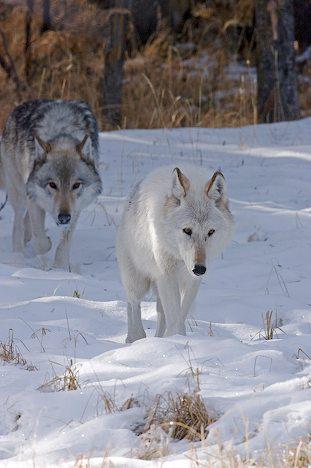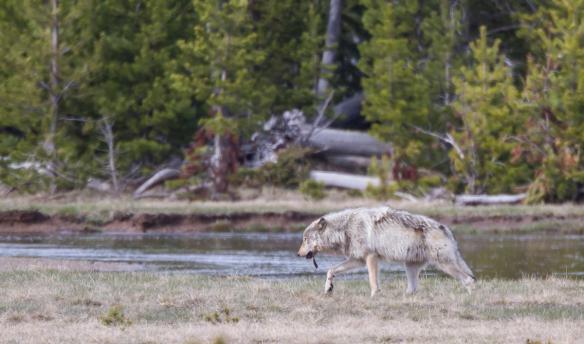The first image is the image on the left, the second image is the image on the right. Assess this claim about the two images: "A single wolf is in a watery area in the image on the right.". Correct or not? Answer yes or no. Yes. The first image is the image on the left, the second image is the image on the right. For the images shown, is this caption "One image features a wolf on snowy ground, and the other includes a body of water and at least one wolf." true? Answer yes or no. Yes. 